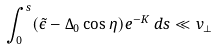<formula> <loc_0><loc_0><loc_500><loc_500>\int _ { 0 } ^ { s } ( \tilde { \epsilon } - \Delta _ { 0 } \cos \eta ) e ^ { - K } \, d s \ll v _ { \perp }</formula> 